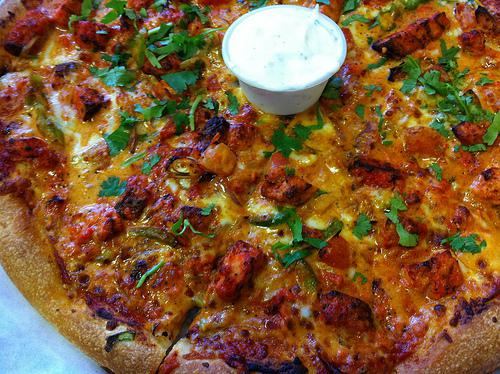Question: where is the dip?
Choices:
A. In a cup.
B. In the restaurant.
C. On the table.
D. In the jar.
Answer with the letter. Answer: A Question: what is in a cup?
Choices:
A. Dip.
B. Coffee.
C. Water.
D. Soda.
Answer with the letter. Answer: A Question: where is the pizza?
Choices:
A. In the box.
B. On the plate.
C. In the oven.
D. Under the cup.
Answer with the letter. Answer: D 